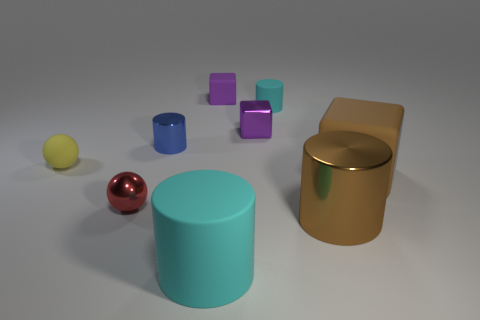Subtract 1 cylinders. How many cylinders are left? 3 Add 1 small brown matte cylinders. How many objects exist? 10 Subtract all spheres. How many objects are left? 7 Subtract all big gray metallic balls. Subtract all big brown blocks. How many objects are left? 8 Add 4 big rubber cubes. How many big rubber cubes are left? 5 Add 8 tiny cyan objects. How many tiny cyan objects exist? 9 Subtract 0 green cubes. How many objects are left? 9 